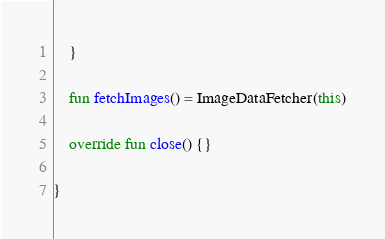<code> <loc_0><loc_0><loc_500><loc_500><_Kotlin_>    }

    fun fetchImages() = ImageDataFetcher(this)

    override fun close() {}

}</code> 